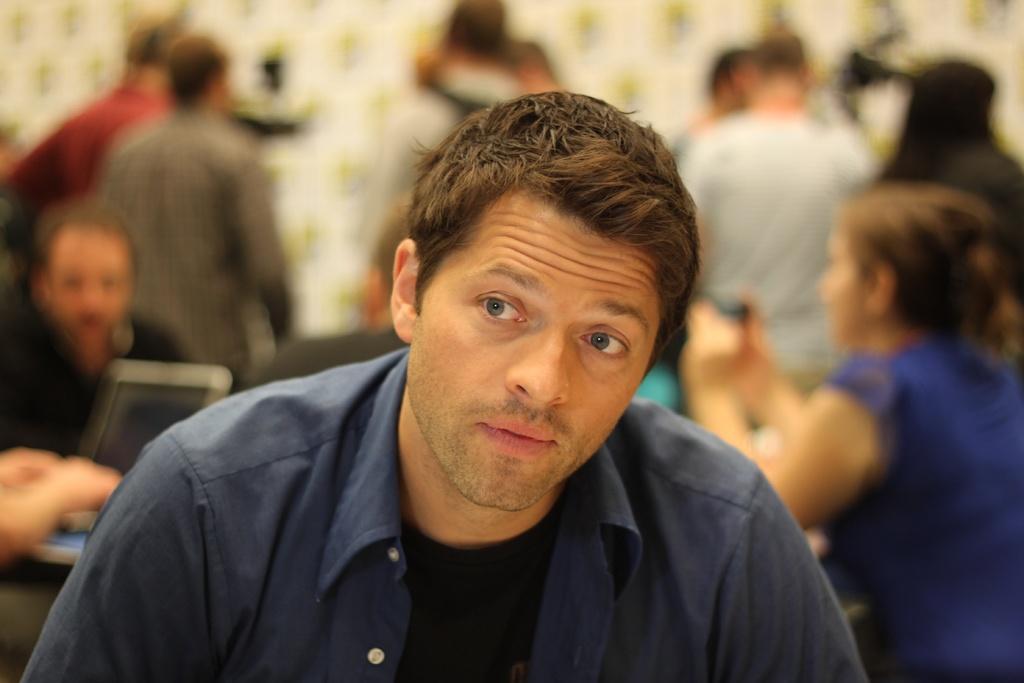Could you give a brief overview of what you see in this image? In this picture we can see a man is sitting and behind the man there are some blurred people sitting and standing. A woman in the blue dress is holding an object. On the left side of the man, it looks like a laptop. 